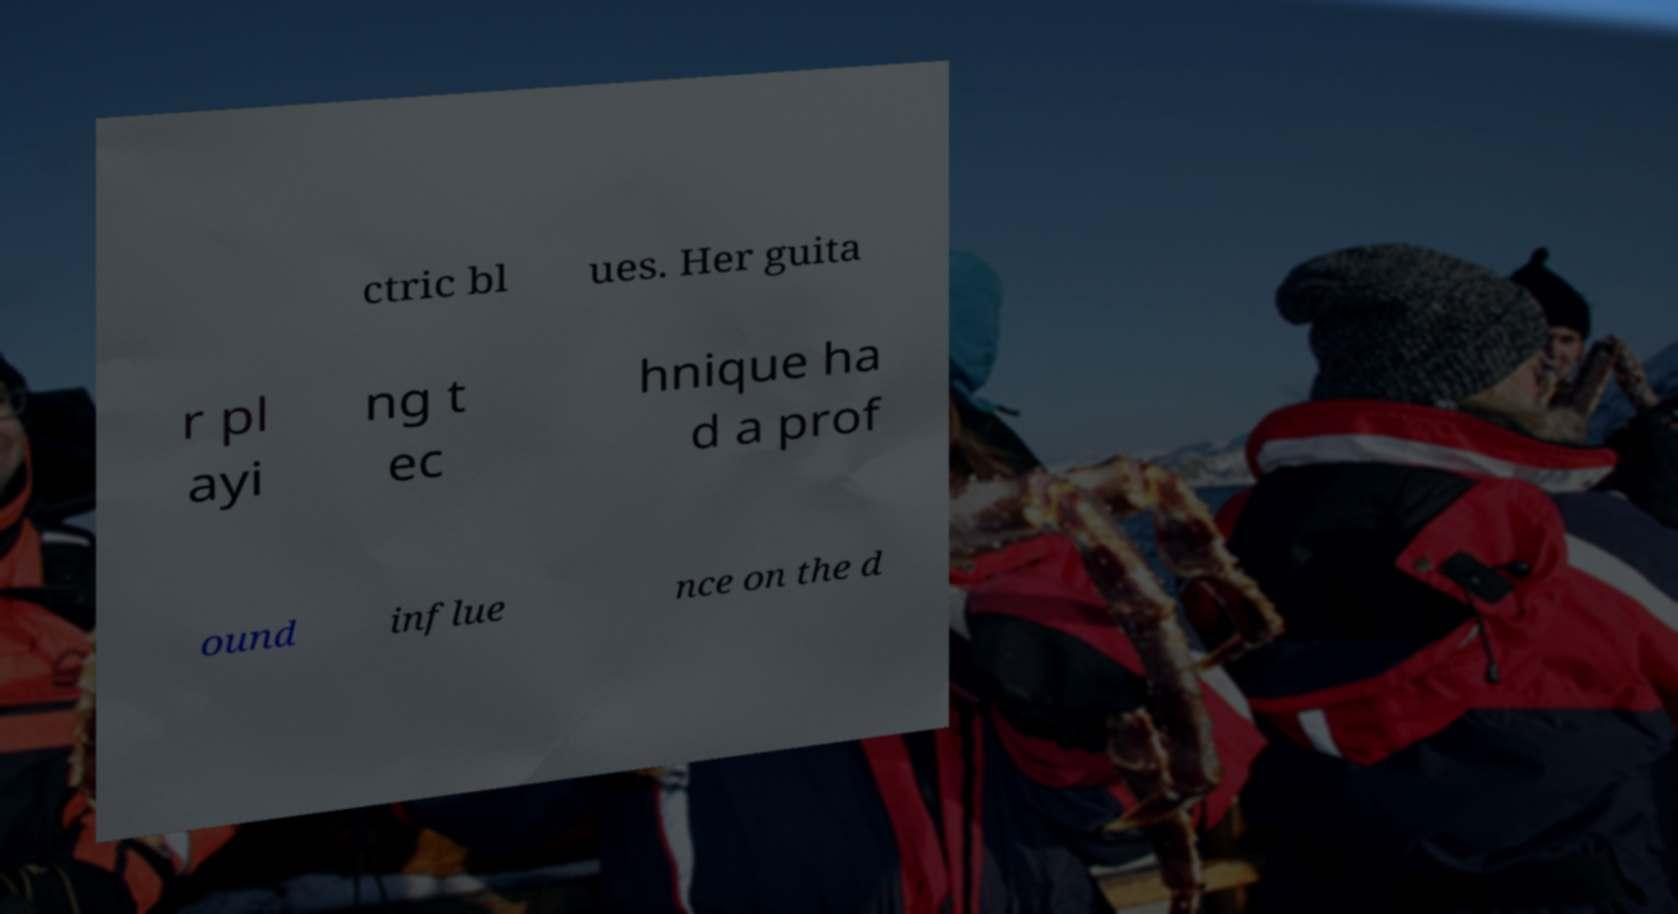For documentation purposes, I need the text within this image transcribed. Could you provide that? ctric bl ues. Her guita r pl ayi ng t ec hnique ha d a prof ound influe nce on the d 